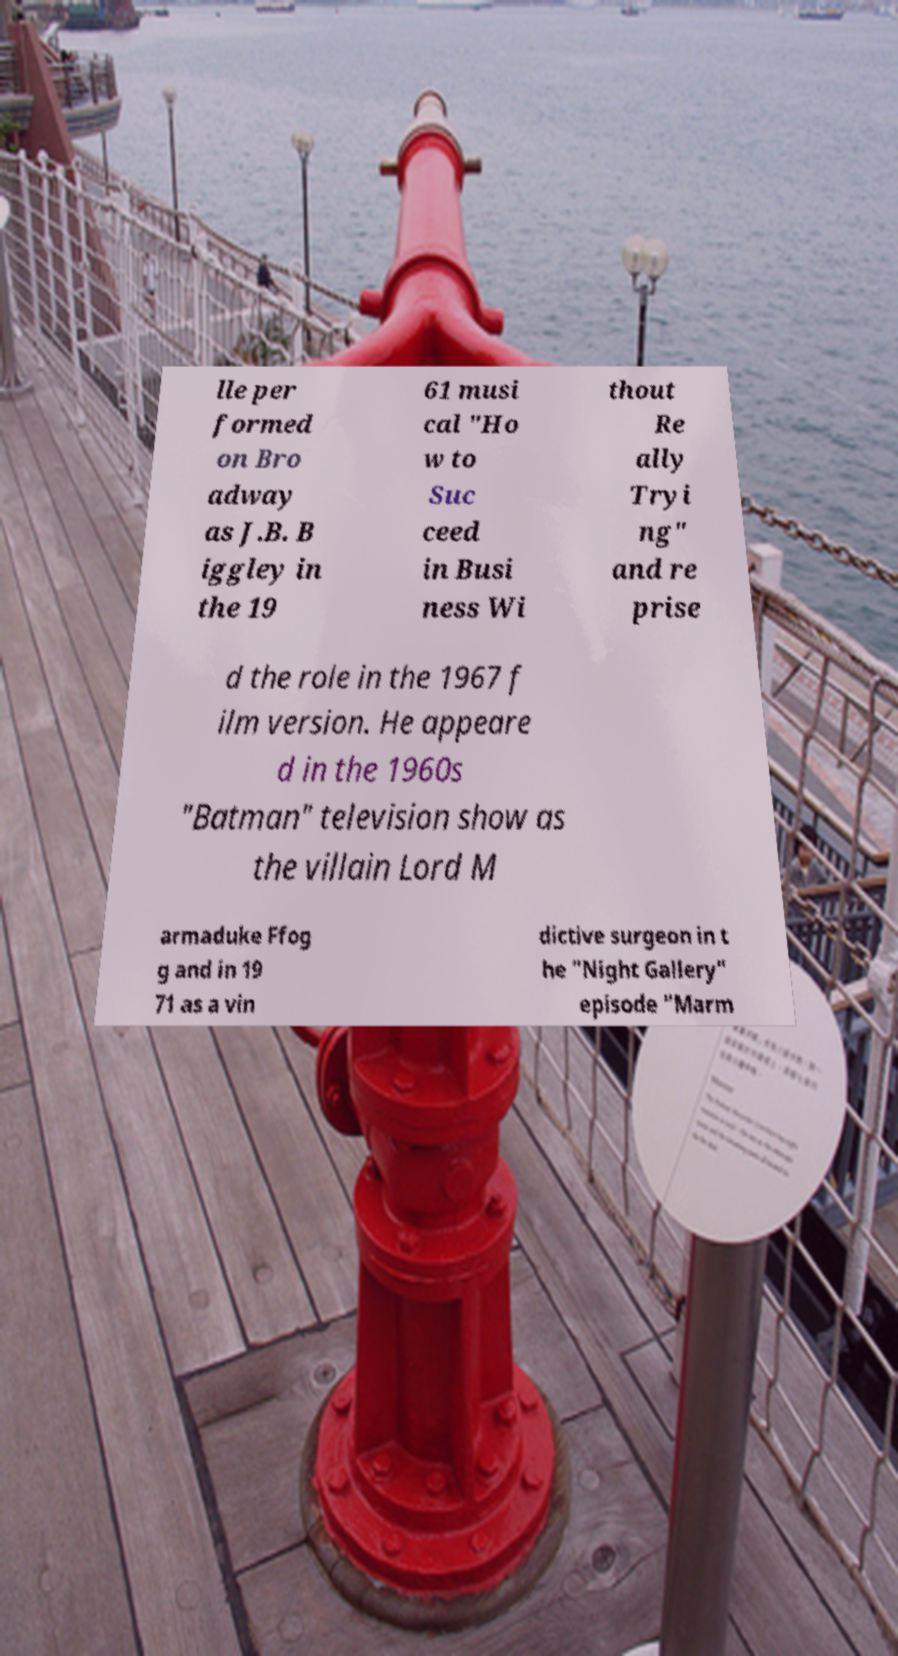Please identify and transcribe the text found in this image. lle per formed on Bro adway as J.B. B iggley in the 19 61 musi cal "Ho w to Suc ceed in Busi ness Wi thout Re ally Tryi ng" and re prise d the role in the 1967 f ilm version. He appeare d in the 1960s "Batman" television show as the villain Lord M armaduke Ffog g and in 19 71 as a vin dictive surgeon in t he "Night Gallery" episode "Marm 